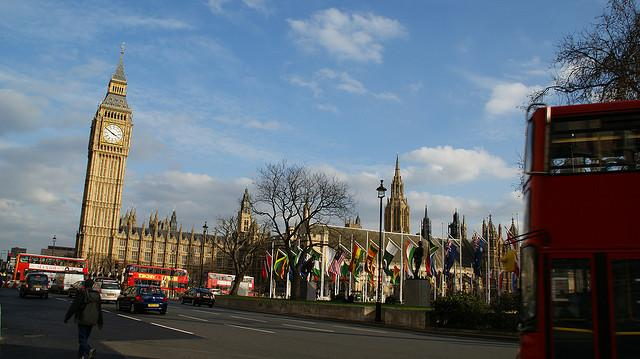Why are there so many buses? Please explain your reasoning. tourist destination. There are so many buses going to a tour destination. 